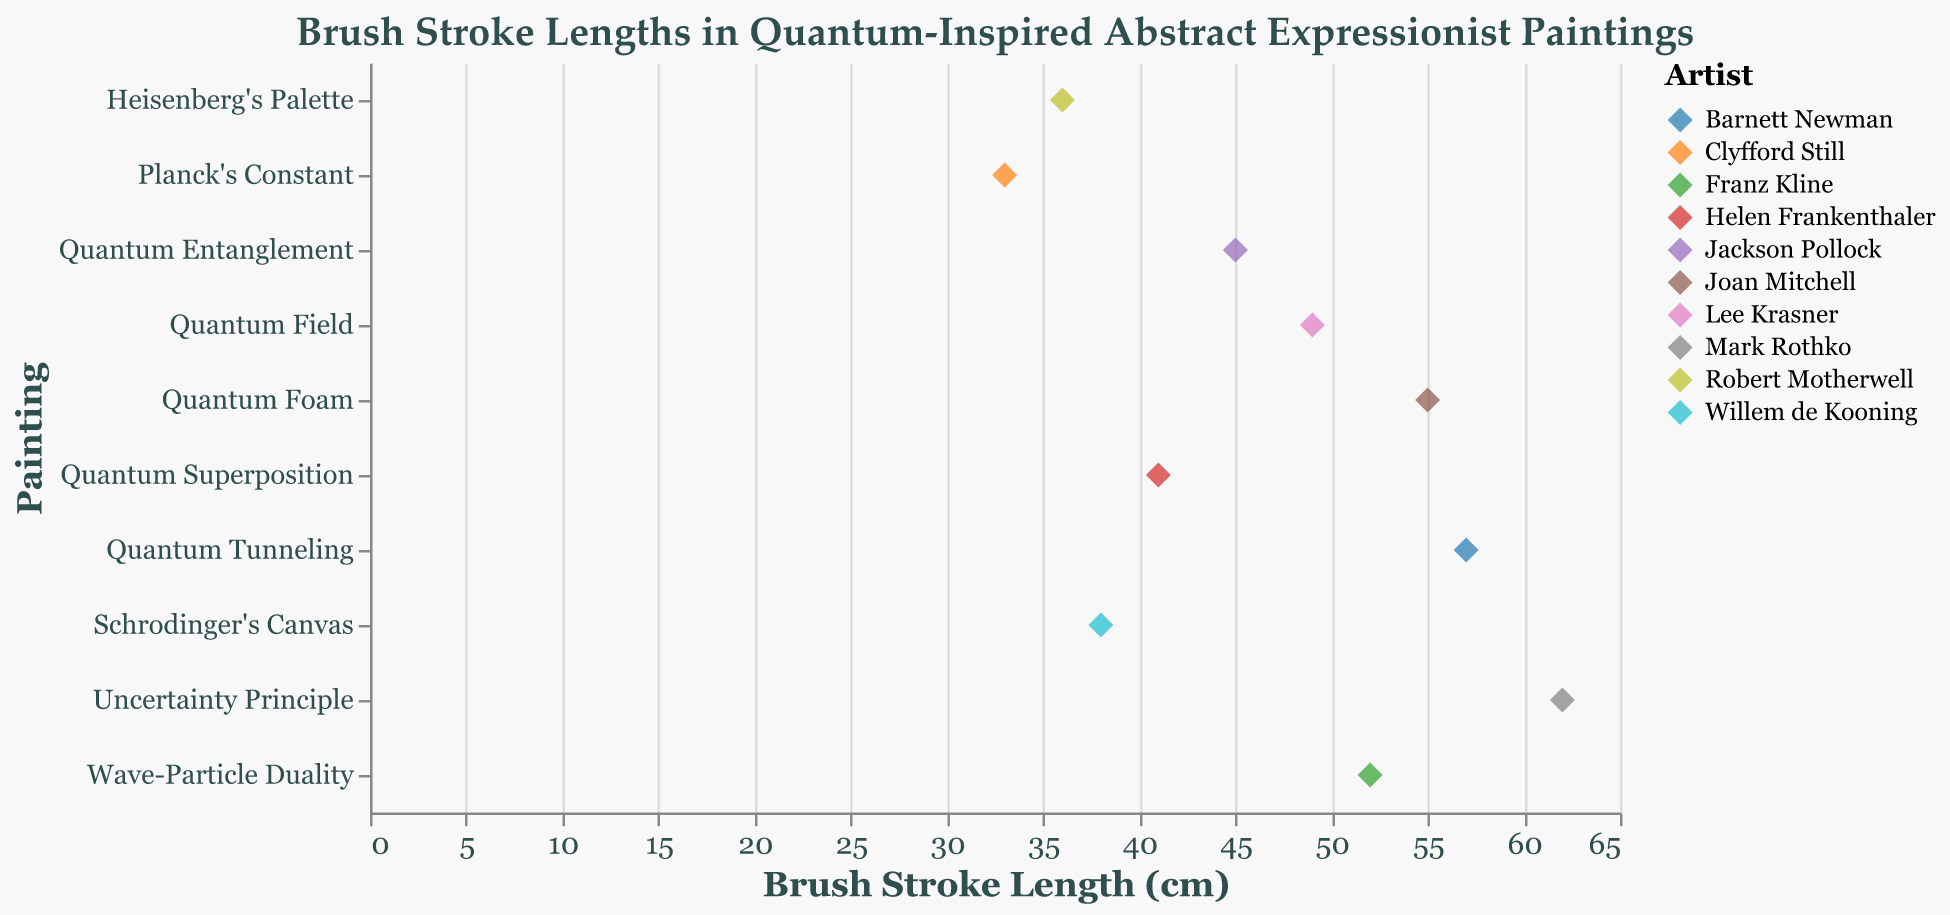What is the title of the strip plot? The title of a plot is usually located at the top and provides a summary of what the figure represents.
Answer: Brush Stroke Lengths in Quantum-Inspired Abstract Expressionist Paintings Which painting has the longest brush stroke length? Identify the painting with the highest value on the Brush Stroke Length (cm) axis.
Answer: Uncertainty Principle What is the brush stroke length of Jackson Pollock's painting? Look for the point corresponding to Jackson Pollock (color) and read the value on the Brush Stroke Length (cm) axis.
Answer: 45 cm How many paintings have brush stroke lengths above 50 cm? Count the number of points with Brush Stroke Length (cm) values greater than 50 cm.
Answer: 4 Which artist has the shortest brush stroke length, and what is that length? Identify the artist and the corresponding value on the Brush Stroke Length (cm) axis that represent the smallest value.
Answer: Clyfford Still, 33 cm What is the average brush stroke length of all the paintings in the dataset? Sum all the brush stroke lengths and divide by the number of paintings (62 + 55 + 57 + 52 + 49 + 45 + 41 + 38 + 36 + 33) / 10.
Answer: 46.8 cm Which two paintings have the closest brush stroke lengths, and what are those lengths? Identify the two points on the Brush Stroke Length (cm) axis with the smallest difference between them.
Answer: Quantum Superposition (41 cm) and Quantum Entanglement (45 cm) Is there a larger variation in brush stroke lengths among Willem de Kooning's and Robert Motherwell's paintings? Compare the brush stroke lengths of both artists and calculate the variation (difference between maximum and minimum values).
Answer: Willem de Kooning's painting (38) and Robert Motherwell's painting (36), so the variation is 2 cm For Helen Frankenthaler, what is the difference between her brush stroke length and the painting 'Heisenberg's Palette'? Subtract the brush stroke length of 'Heisenberg's Palette' from Helen Frankenthaler's brush stroke length (41 - 36).
Answer: 5 cm Which painting has the second longest brush stroke length? Identify the point with the second-highest value on the Brush Stroke Length (cm) axis.
Answer: Quantum Tunneling 